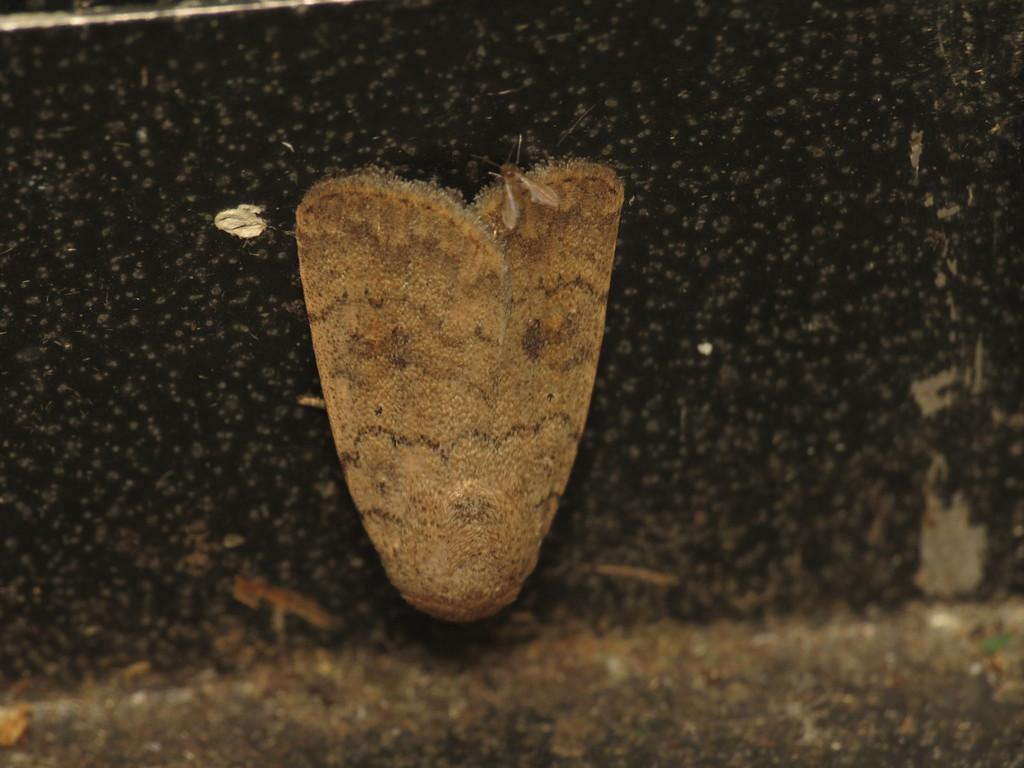How many insects are present in the image? There are two insects in the image. What is the position of the insects in relation to each other? The insects are on top of each other. Where are the insects located in the image? The insects are on a wall. What type of umbrella is being used by the insects in the image? There is no umbrella present in the image; it features two insects on a wall. How many toes can be seen on the insects in the image? Insects do not have toes, so this detail cannot be observed in the image. 